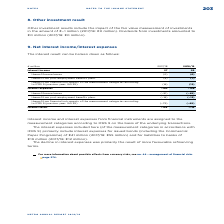According to Metro Ag's financial document, What are Interest income and interest expenses from financial instrument assigned to? assigned to the measurement categories according to IFRS 9 on the basis of the underlying transactions.. The document states: "d interest expenses from financial instruments are assigned to the measurement categories according to IFRS 9 on the basis of the underlying transacti..." Also, What led to the decline in interest expenses? primarily the result of more favourable refinancing terms.. The document states: "The decline in interest expenses was primarily the result of more favourable refinancing terms...." Also, What are the broad components in the table which are used to calculate the interest result? The document shows two values: Interest income and Interest expenses. From the document: "Interest expenses −163 −148 Interest income 27 29..." Additionally, In which year was the interest income larger? Based on the financial document, the answer is 2018/2019. Also, can you calculate: What was the change in interest income in 2018/2019 from 2017/2018? Based on the calculation: 29-27, the result is 2 (in millions). This is based on the information: "Interest income 27 29 Interest income 27 29..." The key data points involved are: 27, 29. Also, can you calculate: What was the percentage change in interest income in 2018/2019 from 2017/2018? To answer this question, I need to perform calculations using the financial data. The calculation is: (29-27)/27, which equals 7.41 (percentage). This is based on the information: "Interest income 27 29 Interest income 27 29..." The key data points involved are: 27, 29. 